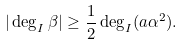Convert formula to latex. <formula><loc_0><loc_0><loc_500><loc_500>| \deg _ { I } \beta | \geq \frac { 1 } { 2 } \deg _ { I } ( a \alpha ^ { 2 } ) .</formula> 